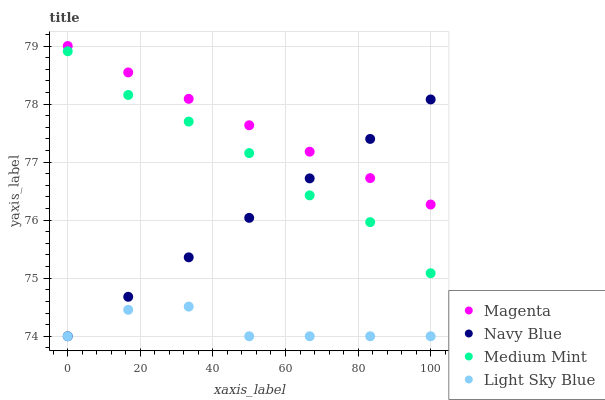Does Light Sky Blue have the minimum area under the curve?
Answer yes or no. Yes. Does Magenta have the maximum area under the curve?
Answer yes or no. Yes. Does Navy Blue have the minimum area under the curve?
Answer yes or no. No. Does Navy Blue have the maximum area under the curve?
Answer yes or no. No. Is Navy Blue the smoothest?
Answer yes or no. Yes. Is Light Sky Blue the roughest?
Answer yes or no. Yes. Is Magenta the smoothest?
Answer yes or no. No. Is Magenta the roughest?
Answer yes or no. No. Does Navy Blue have the lowest value?
Answer yes or no. Yes. Does Magenta have the lowest value?
Answer yes or no. No. Does Magenta have the highest value?
Answer yes or no. Yes. Does Navy Blue have the highest value?
Answer yes or no. No. Is Medium Mint less than Magenta?
Answer yes or no. Yes. Is Magenta greater than Medium Mint?
Answer yes or no. Yes. Does Navy Blue intersect Magenta?
Answer yes or no. Yes. Is Navy Blue less than Magenta?
Answer yes or no. No. Is Navy Blue greater than Magenta?
Answer yes or no. No. Does Medium Mint intersect Magenta?
Answer yes or no. No. 